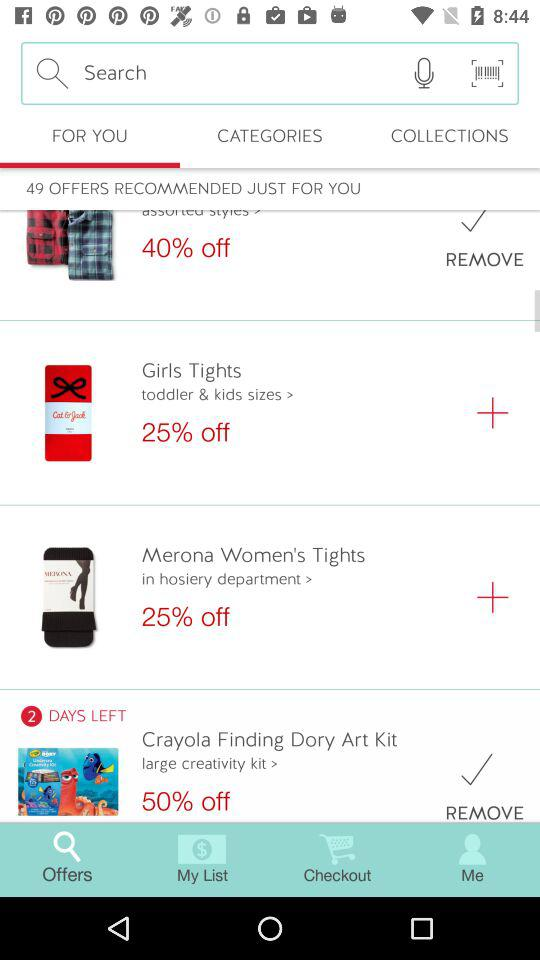Which tab is open? The open tab is "FOR YOU". 